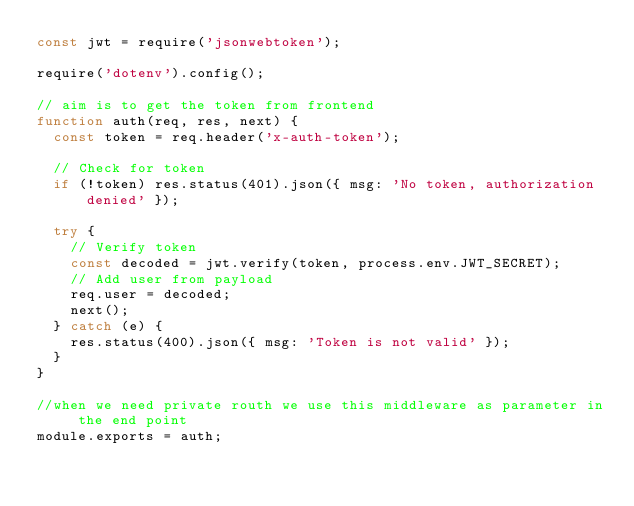Convert code to text. <code><loc_0><loc_0><loc_500><loc_500><_JavaScript_>const jwt = require('jsonwebtoken');

require('dotenv').config();

// aim is to get the token from frontend
function auth(req, res, next) {
  const token = req.header('x-auth-token');

  // Check for token
  if (!token) res.status(401).json({ msg: 'No token, authorization denied' });

  try {
    // Verify token
    const decoded = jwt.verify(token, process.env.JWT_SECRET);
    // Add user from payload
    req.user = decoded;
    next();
  } catch (e) {
    res.status(400).json({ msg: 'Token is not valid' });
  }
}

//when we need private routh we use this middleware as parameter in the end point
module.exports = auth;
</code> 